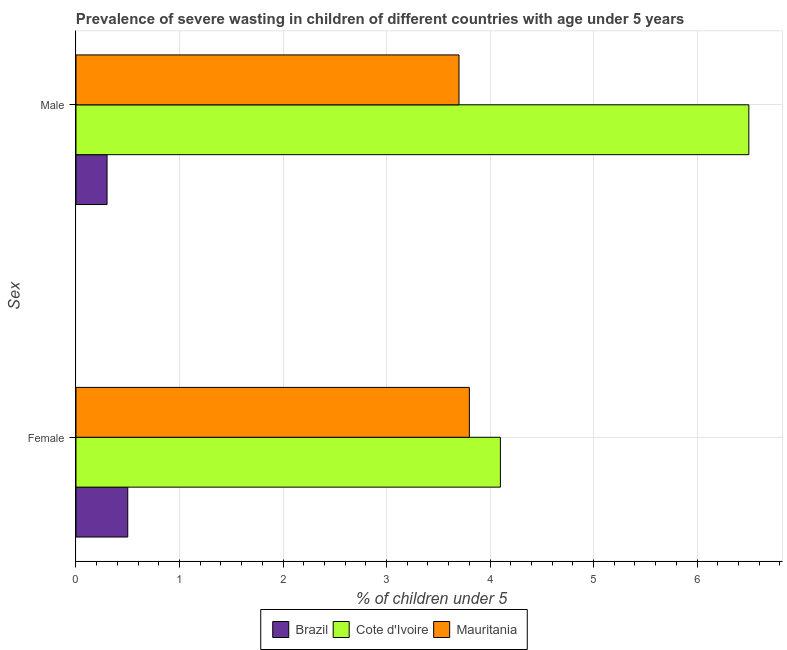How many bars are there on the 1st tick from the top?
Your response must be concise. 3. How many bars are there on the 1st tick from the bottom?
Your answer should be very brief. 3. What is the label of the 1st group of bars from the top?
Offer a terse response. Male. What is the percentage of undernourished female children in Mauritania?
Offer a very short reply. 3.8. Across all countries, what is the minimum percentage of undernourished female children?
Offer a terse response. 0.5. In which country was the percentage of undernourished male children maximum?
Your response must be concise. Cote d'Ivoire. In which country was the percentage of undernourished male children minimum?
Offer a very short reply. Brazil. What is the total percentage of undernourished female children in the graph?
Your response must be concise. 8.4. What is the difference between the percentage of undernourished female children in Cote d'Ivoire and that in Mauritania?
Your response must be concise. 0.3. What is the difference between the percentage of undernourished female children in Brazil and the percentage of undernourished male children in Cote d'Ivoire?
Provide a short and direct response. -6. What is the average percentage of undernourished female children per country?
Your answer should be compact. 2.8. What is the difference between the percentage of undernourished female children and percentage of undernourished male children in Brazil?
Offer a very short reply. 0.2. What is the ratio of the percentage of undernourished male children in Brazil to that in Cote d'Ivoire?
Give a very brief answer. 0.05. Is the percentage of undernourished male children in Brazil less than that in Cote d'Ivoire?
Your response must be concise. Yes. In how many countries, is the percentage of undernourished male children greater than the average percentage of undernourished male children taken over all countries?
Keep it short and to the point. 2. What does the 3rd bar from the top in Male represents?
Your answer should be compact. Brazil. How many bars are there?
Offer a very short reply. 6. Are all the bars in the graph horizontal?
Offer a terse response. Yes. How many countries are there in the graph?
Your answer should be compact. 3. Does the graph contain any zero values?
Offer a terse response. No. Where does the legend appear in the graph?
Provide a short and direct response. Bottom center. How are the legend labels stacked?
Make the answer very short. Horizontal. What is the title of the graph?
Keep it short and to the point. Prevalence of severe wasting in children of different countries with age under 5 years. What is the label or title of the X-axis?
Give a very brief answer.  % of children under 5. What is the label or title of the Y-axis?
Your response must be concise. Sex. What is the  % of children under 5 in Brazil in Female?
Provide a succinct answer. 0.5. What is the  % of children under 5 in Cote d'Ivoire in Female?
Make the answer very short. 4.1. What is the  % of children under 5 in Mauritania in Female?
Give a very brief answer. 3.8. What is the  % of children under 5 of Brazil in Male?
Your answer should be very brief. 0.3. What is the  % of children under 5 in Mauritania in Male?
Provide a short and direct response. 3.7. Across all Sex, what is the maximum  % of children under 5 of Mauritania?
Your response must be concise. 3.8. Across all Sex, what is the minimum  % of children under 5 of Brazil?
Offer a very short reply. 0.3. Across all Sex, what is the minimum  % of children under 5 of Cote d'Ivoire?
Your answer should be very brief. 4.1. Across all Sex, what is the minimum  % of children under 5 in Mauritania?
Offer a terse response. 3.7. What is the total  % of children under 5 of Mauritania in the graph?
Your response must be concise. 7.5. What is the difference between the  % of children under 5 of Brazil in Female and that in Male?
Your answer should be compact. 0.2. What is the difference between the  % of children under 5 in Brazil in Female and the  % of children under 5 in Cote d'Ivoire in Male?
Your answer should be very brief. -6. What is the average  % of children under 5 in Mauritania per Sex?
Give a very brief answer. 3.75. What is the difference between the  % of children under 5 in Brazil and  % of children under 5 in Mauritania in Female?
Offer a very short reply. -3.3. What is the difference between the  % of children under 5 in Cote d'Ivoire and  % of children under 5 in Mauritania in Female?
Provide a short and direct response. 0.3. What is the difference between the  % of children under 5 of Brazil and  % of children under 5 of Cote d'Ivoire in Male?
Give a very brief answer. -6.2. What is the difference between the  % of children under 5 in Cote d'Ivoire and  % of children under 5 in Mauritania in Male?
Provide a short and direct response. 2.8. What is the ratio of the  % of children under 5 of Cote d'Ivoire in Female to that in Male?
Ensure brevity in your answer.  0.63. What is the difference between the highest and the second highest  % of children under 5 of Cote d'Ivoire?
Your answer should be compact. 2.4. What is the difference between the highest and the lowest  % of children under 5 of Cote d'Ivoire?
Provide a short and direct response. 2.4. 